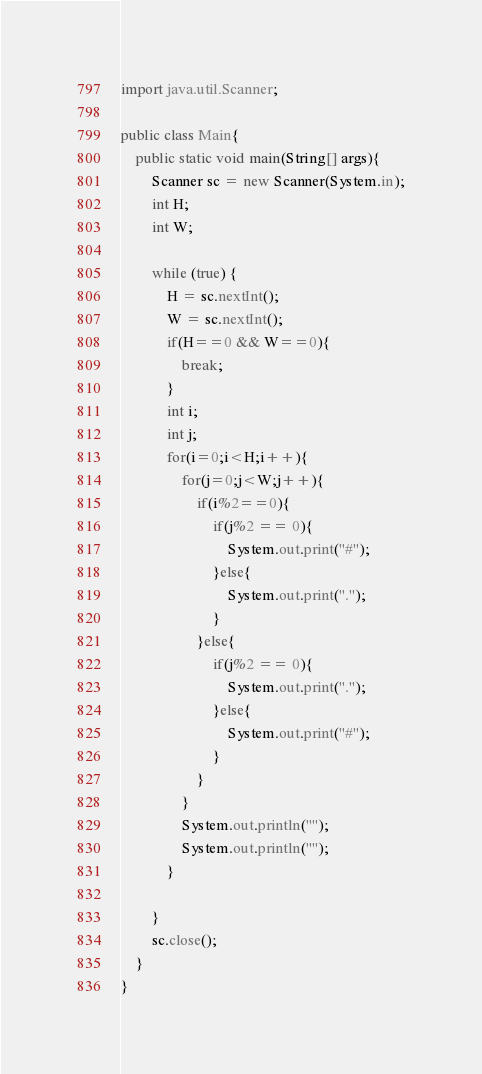Convert code to text. <code><loc_0><loc_0><loc_500><loc_500><_Java_>import java.util.Scanner;

public class Main{
    public static void main(String[] args){
        Scanner sc = new Scanner(System.in);
        int H;
        int W;

        while (true) {
            H = sc.nextInt();
            W = sc.nextInt();
            if(H==0 && W==0){
                break;
            }
            int i;
            int j;
            for(i=0;i<H;i++){
                for(j=0;j<W;j++){
                    if(i%2==0){
                        if(j%2 == 0){
                            System.out.print("#");
                        }else{
                            System.out.print(".");
                        }        
                    }else{
                        if(j%2 == 0){
                            System.out.print(".");
                        }else{
                            System.out.print("#");
                        }
                    }
                }
                System.out.println("");
                System.out.println("");
            }
        
        }
        sc.close();
    }
}
</code> 